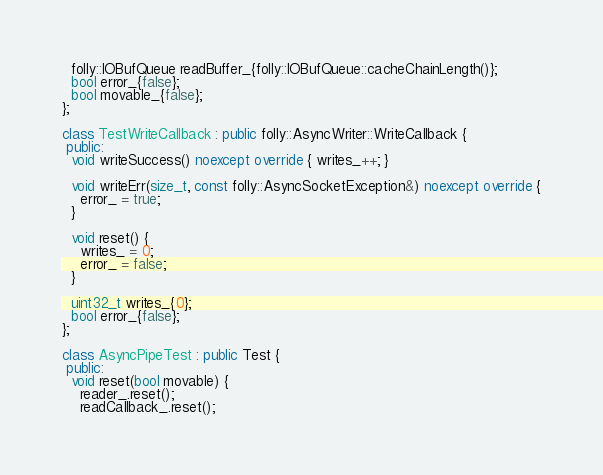<code> <loc_0><loc_0><loc_500><loc_500><_C++_>  folly::IOBufQueue readBuffer_{folly::IOBufQueue::cacheChainLength()};
  bool error_{false};
  bool movable_{false};
};

class TestWriteCallback : public folly::AsyncWriter::WriteCallback {
 public:
  void writeSuccess() noexcept override { writes_++; }

  void writeErr(size_t, const folly::AsyncSocketException&) noexcept override {
    error_ = true;
  }

  void reset() {
    writes_ = 0;
    error_ = false;
  }

  uint32_t writes_{0};
  bool error_{false};
};

class AsyncPipeTest : public Test {
 public:
  void reset(bool movable) {
    reader_.reset();
    readCallback_.reset();</code> 